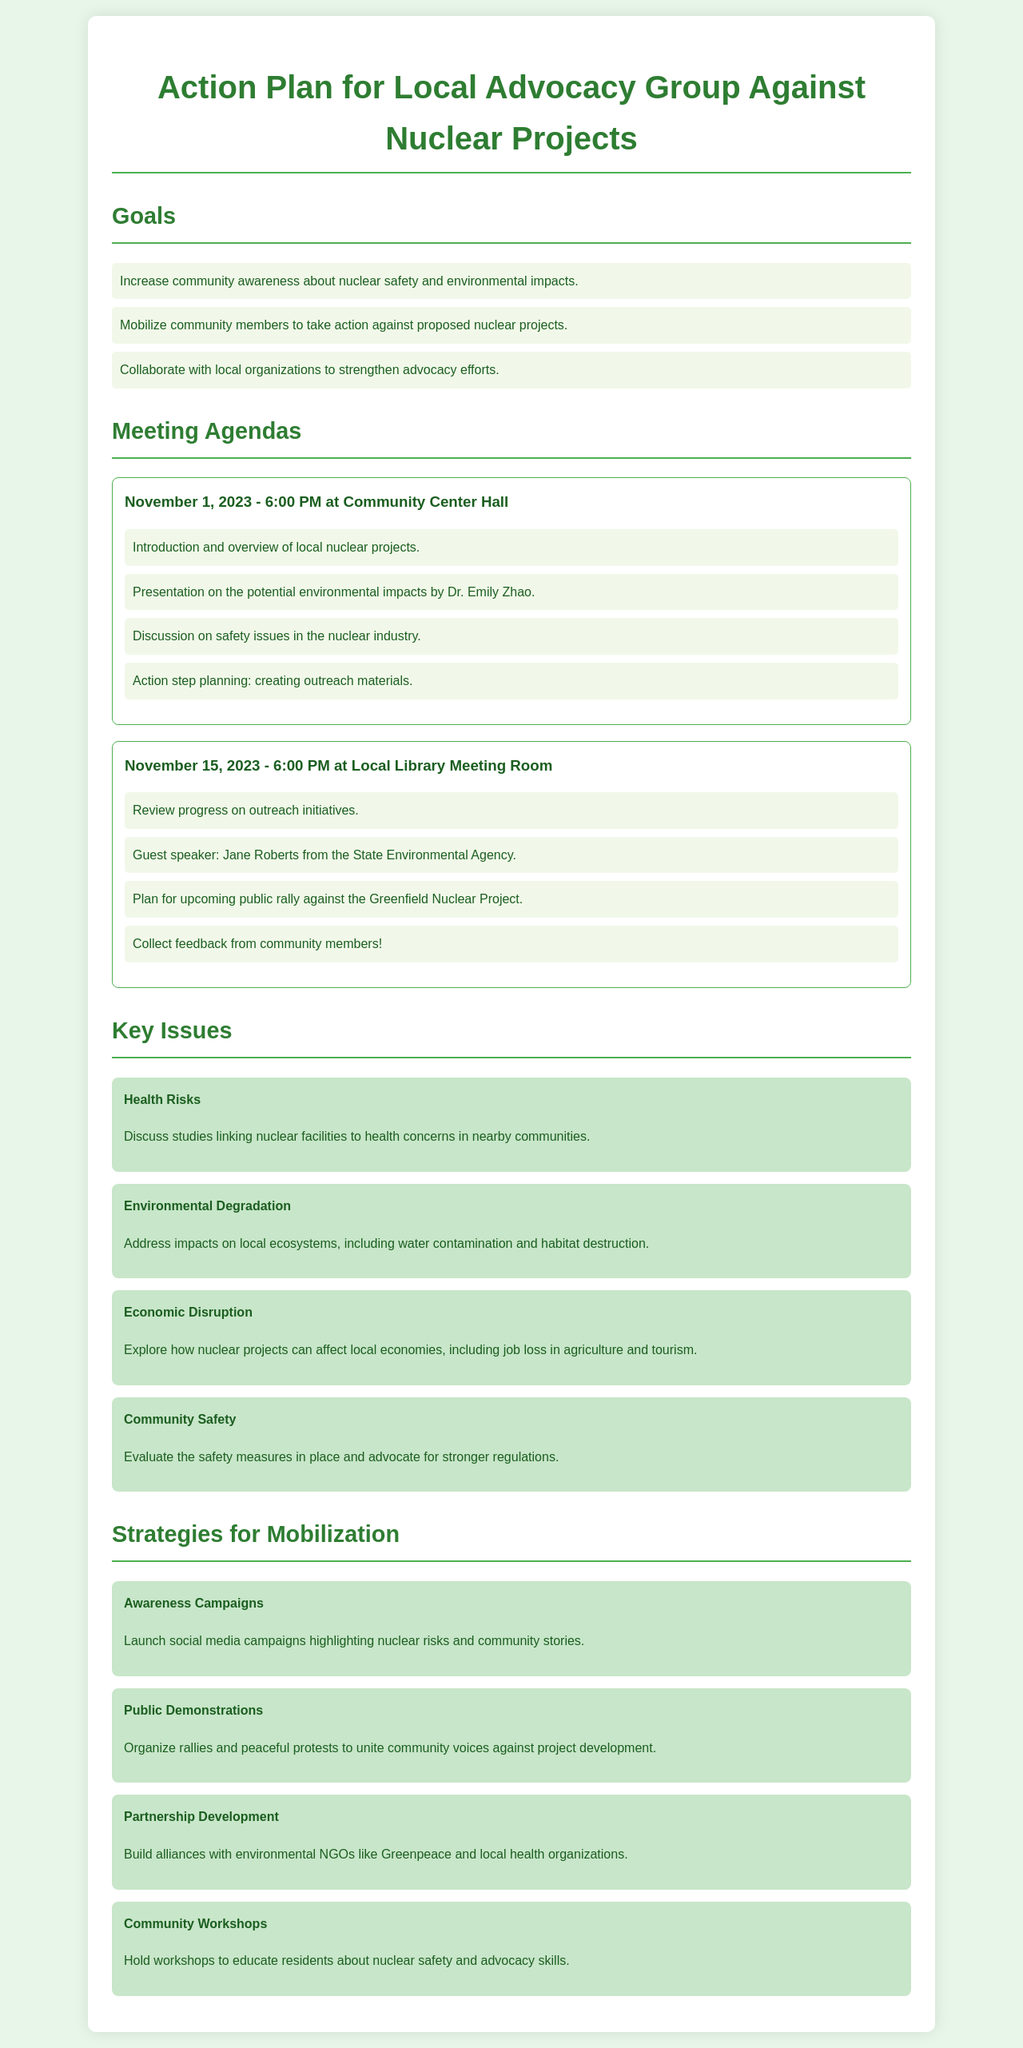What is the date of the first meeting? The first meeting is scheduled for November 1, 2023, as listed in the meeting agendas.
Answer: November 1, 2023 Who is the guest speaker for the second meeting? The guest speaker for the second meeting is Jane Roberts from the State Environmental Agency, mentioned in the meeting agenda.
Answer: Jane Roberts What is one of the key issues highlighted in the document? The document identifies several key issues, such as health risks, environmental degradation, and more. One mentioned is health risks.
Answer: Health Risks How many strategies for mobilization are outlined in the document? The document lists four strategies for community mobilization against nuclear projects.
Answer: Four What is the location of the second meeting? The location for the second meeting is at the Local Library Meeting Room, as indicated in the meeting agendas.
Answer: Local Library Meeting Room What is the primary goal of the advocacy group? The primary goal includes increasing community awareness about nuclear safety and environmental impacts, as detailed in the goals section.
Answer: Increase community awareness What type of campaign is suggested for raising awareness? The document suggests launching social media campaigns as part of the awareness strategies.
Answer: Social media campaigns What are community workshops intended to educate about? The community workshops are intended to educate residents about nuclear safety and advocacy skills, as stated in the strategies for mobilization.
Answer: Nuclear safety and advocacy skills 